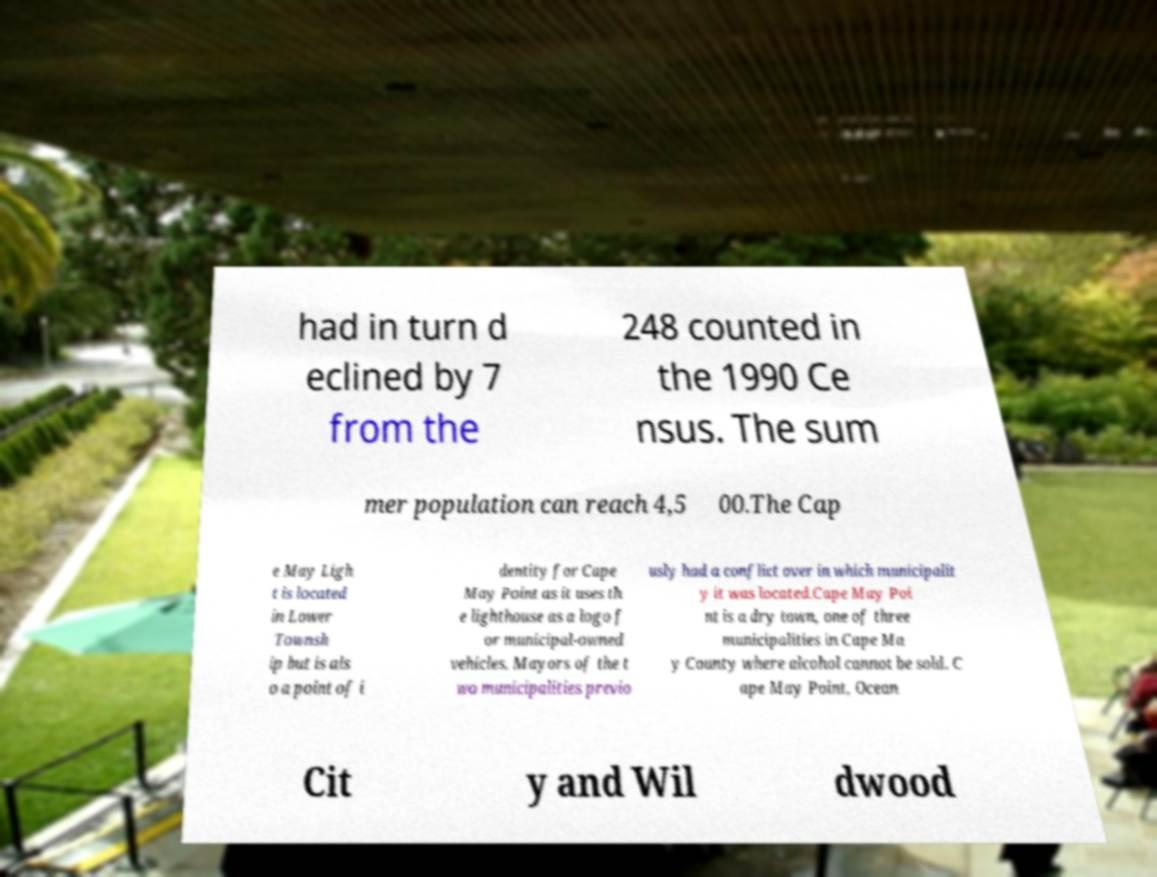Can you read and provide the text displayed in the image?This photo seems to have some interesting text. Can you extract and type it out for me? had in turn d eclined by 7 from the 248 counted in the 1990 Ce nsus. The sum mer population can reach 4,5 00.The Cap e May Ligh t is located in Lower Townsh ip but is als o a point of i dentity for Cape May Point as it uses th e lighthouse as a logo f or municipal-owned vehicles. Mayors of the t wo municipalities previo usly had a conflict over in which municipalit y it was located.Cape May Poi nt is a dry town, one of three municipalities in Cape Ma y County where alcohol cannot be sold. C ape May Point, Ocean Cit y and Wil dwood 